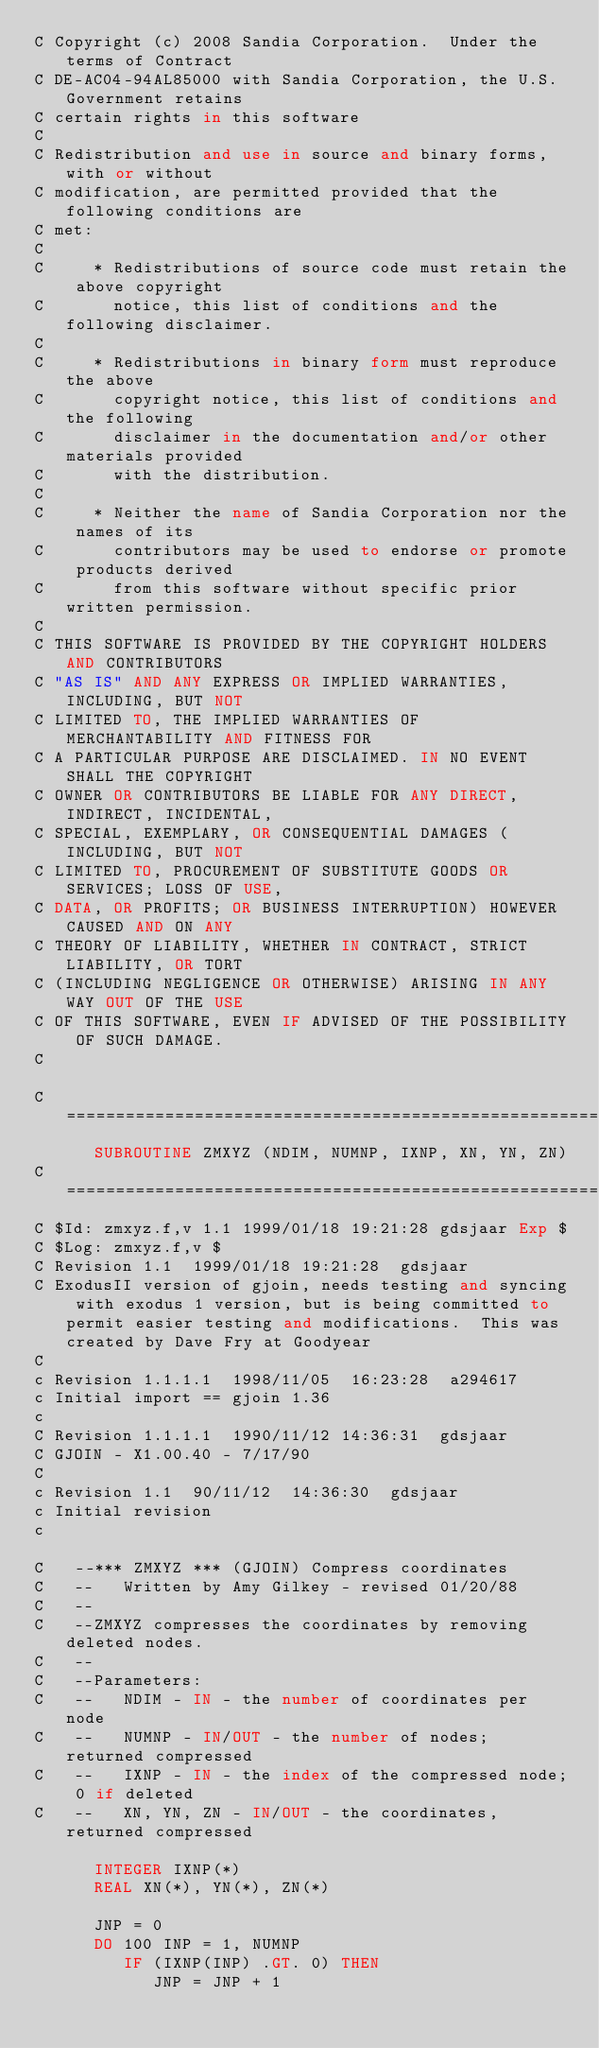<code> <loc_0><loc_0><loc_500><loc_500><_FORTRAN_>C Copyright (c) 2008 Sandia Corporation.  Under the terms of Contract
C DE-AC04-94AL85000 with Sandia Corporation, the U.S. Government retains
C certain rights in this software
C 
C Redistribution and use in source and binary forms, with or without
C modification, are permitted provided that the following conditions are
C met:
C 
C     * Redistributions of source code must retain the above copyright
C       notice, this list of conditions and the following disclaimer.
C 
C     * Redistributions in binary form must reproduce the above
C       copyright notice, this list of conditions and the following
C       disclaimer in the documentation and/or other materials provided
C       with the distribution.
C 
C     * Neither the name of Sandia Corporation nor the names of its
C       contributors may be used to endorse or promote products derived
C       from this software without specific prior written permission.
C 
C THIS SOFTWARE IS PROVIDED BY THE COPYRIGHT HOLDERS AND CONTRIBUTORS
C "AS IS" AND ANY EXPRESS OR IMPLIED WARRANTIES, INCLUDING, BUT NOT
C LIMITED TO, THE IMPLIED WARRANTIES OF MERCHANTABILITY AND FITNESS FOR
C A PARTICULAR PURPOSE ARE DISCLAIMED. IN NO EVENT SHALL THE COPYRIGHT
C OWNER OR CONTRIBUTORS BE LIABLE FOR ANY DIRECT, INDIRECT, INCIDENTAL,
C SPECIAL, EXEMPLARY, OR CONSEQUENTIAL DAMAGES (INCLUDING, BUT NOT
C LIMITED TO, PROCUREMENT OF SUBSTITUTE GOODS OR SERVICES; LOSS OF USE,
C DATA, OR PROFITS; OR BUSINESS INTERRUPTION) HOWEVER CAUSED AND ON ANY
C THEORY OF LIABILITY, WHETHER IN CONTRACT, STRICT LIABILITY, OR TORT
C (INCLUDING NEGLIGENCE OR OTHERWISE) ARISING IN ANY WAY OUT OF THE USE
C OF THIS SOFTWARE, EVEN IF ADVISED OF THE POSSIBILITY OF SUCH DAMAGE.
C 

C=======================================================================
      SUBROUTINE ZMXYZ (NDIM, NUMNP, IXNP, XN, YN, ZN)
C=======================================================================
C $Id: zmxyz.f,v 1.1 1999/01/18 19:21:28 gdsjaar Exp $
C $Log: zmxyz.f,v $
C Revision 1.1  1999/01/18 19:21:28  gdsjaar
C ExodusII version of gjoin, needs testing and syncing with exodus 1 version, but is being committed to permit easier testing and modifications.  This was created by Dave Fry at Goodyear
C
c Revision 1.1.1.1  1998/11/05  16:23:28  a294617
c Initial import == gjoin 1.36
c
C Revision 1.1.1.1  1990/11/12 14:36:31  gdsjaar
C GJOIN - X1.00.40 - 7/17/90
C
c Revision 1.1  90/11/12  14:36:30  gdsjaar
c Initial revision
c 

C   --*** ZMXYZ *** (GJOIN) Compress coordinates
C   --   Written by Amy Gilkey - revised 01/20/88
C   --
C   --ZMXYZ compresses the coordinates by removing deleted nodes.
C   --
C   --Parameters:
C   --   NDIM - IN - the number of coordinates per node
C   --   NUMNP - IN/OUT - the number of nodes; returned compressed
C   --   IXNP - IN - the index of the compressed node; 0 if deleted
C   --   XN, YN, ZN - IN/OUT - the coordinates, returned compressed

      INTEGER IXNP(*)
      REAL XN(*), YN(*), ZN(*)

      JNP = 0
      DO 100 INP = 1, NUMNP
         IF (IXNP(INP) .GT. 0) THEN
            JNP = JNP + 1</code> 